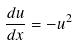<formula> <loc_0><loc_0><loc_500><loc_500>\frac { d u } { d x } = - u ^ { 2 }</formula> 